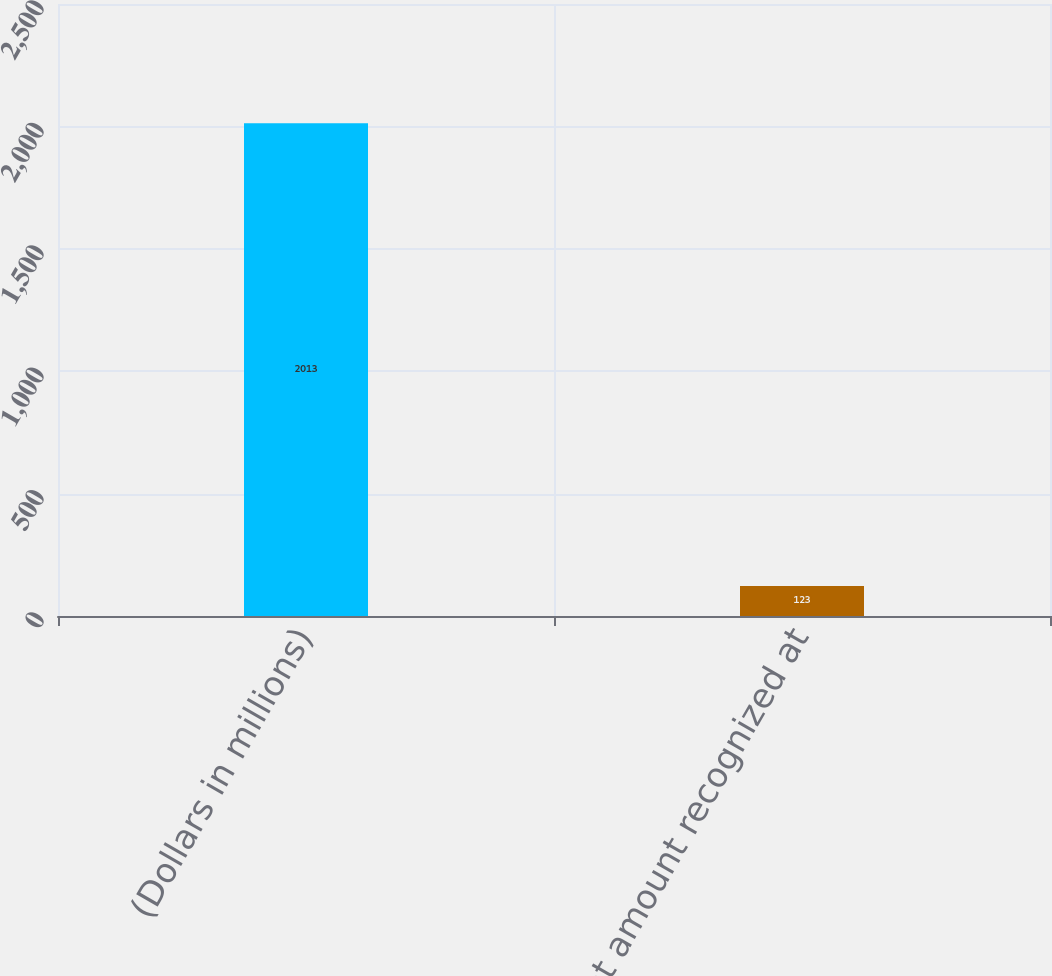Convert chart to OTSL. <chart><loc_0><loc_0><loc_500><loc_500><bar_chart><fcel>(Dollars in millions)<fcel>Net amount recognized at<nl><fcel>2013<fcel>123<nl></chart> 